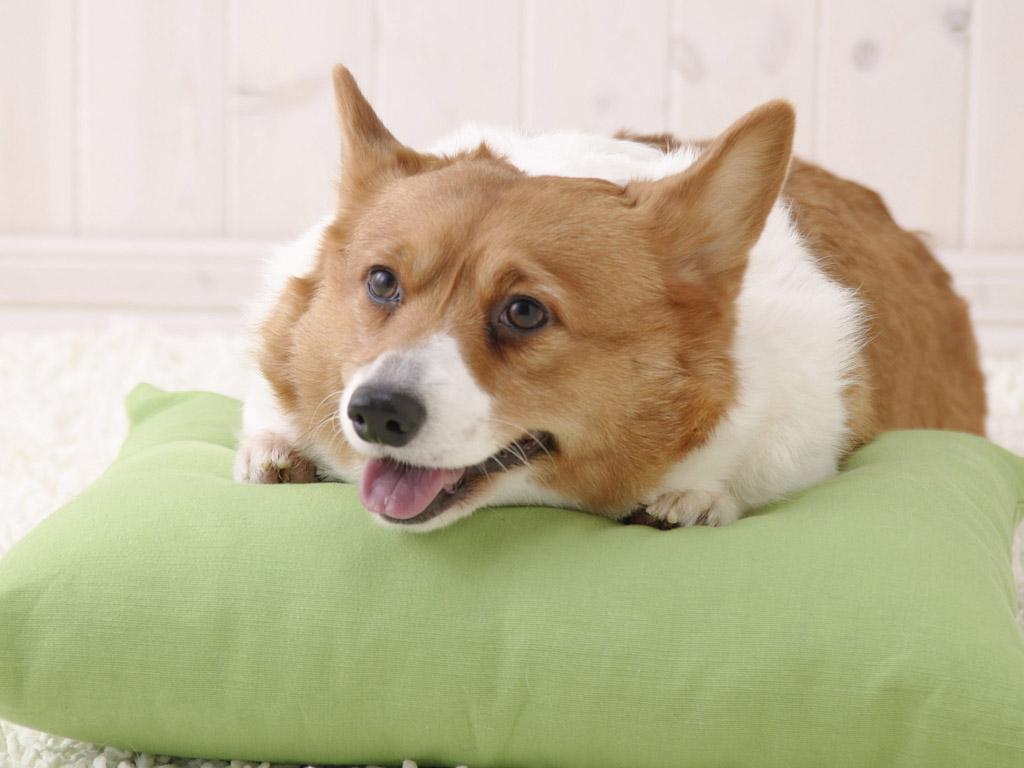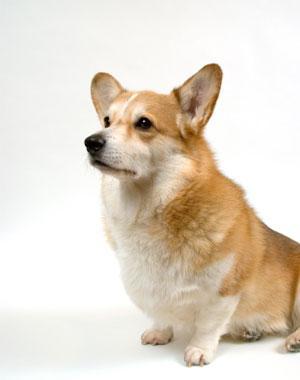The first image is the image on the left, the second image is the image on the right. For the images displayed, is the sentence "One dog is sitting and the other is laying flat with paws forward." factually correct? Answer yes or no. Yes. 